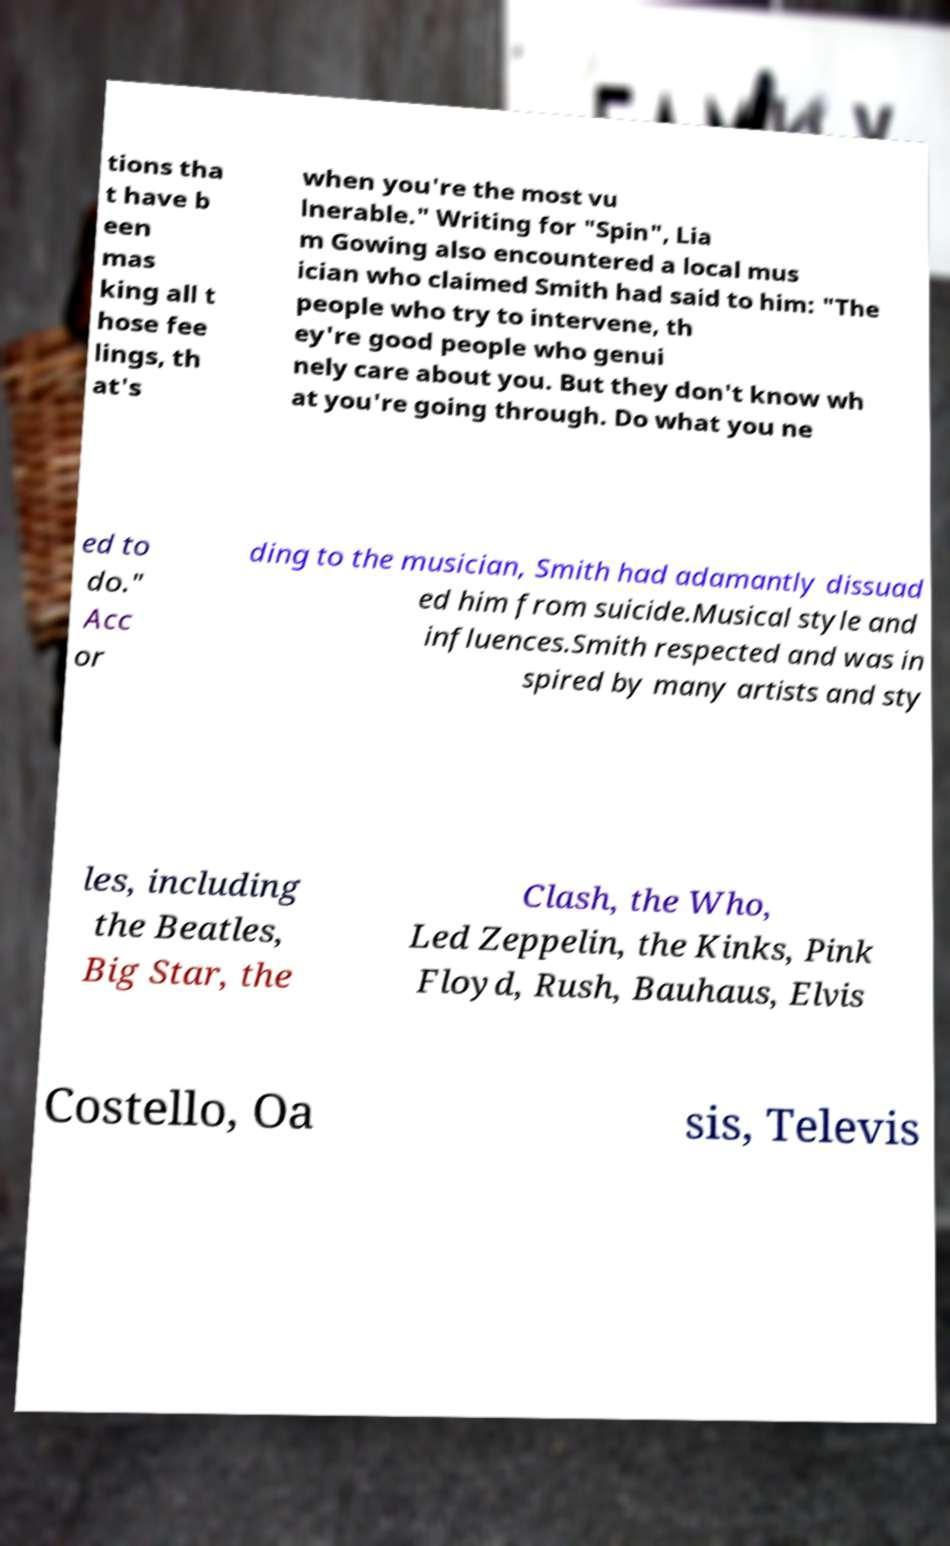There's text embedded in this image that I need extracted. Can you transcribe it verbatim? tions tha t have b een mas king all t hose fee lings, th at's when you're the most vu lnerable." Writing for "Spin", Lia m Gowing also encountered a local mus ician who claimed Smith had said to him: "The people who try to intervene, th ey're good people who genui nely care about you. But they don't know wh at you're going through. Do what you ne ed to do." Acc or ding to the musician, Smith had adamantly dissuad ed him from suicide.Musical style and influences.Smith respected and was in spired by many artists and sty les, including the Beatles, Big Star, the Clash, the Who, Led Zeppelin, the Kinks, Pink Floyd, Rush, Bauhaus, Elvis Costello, Oa sis, Televis 